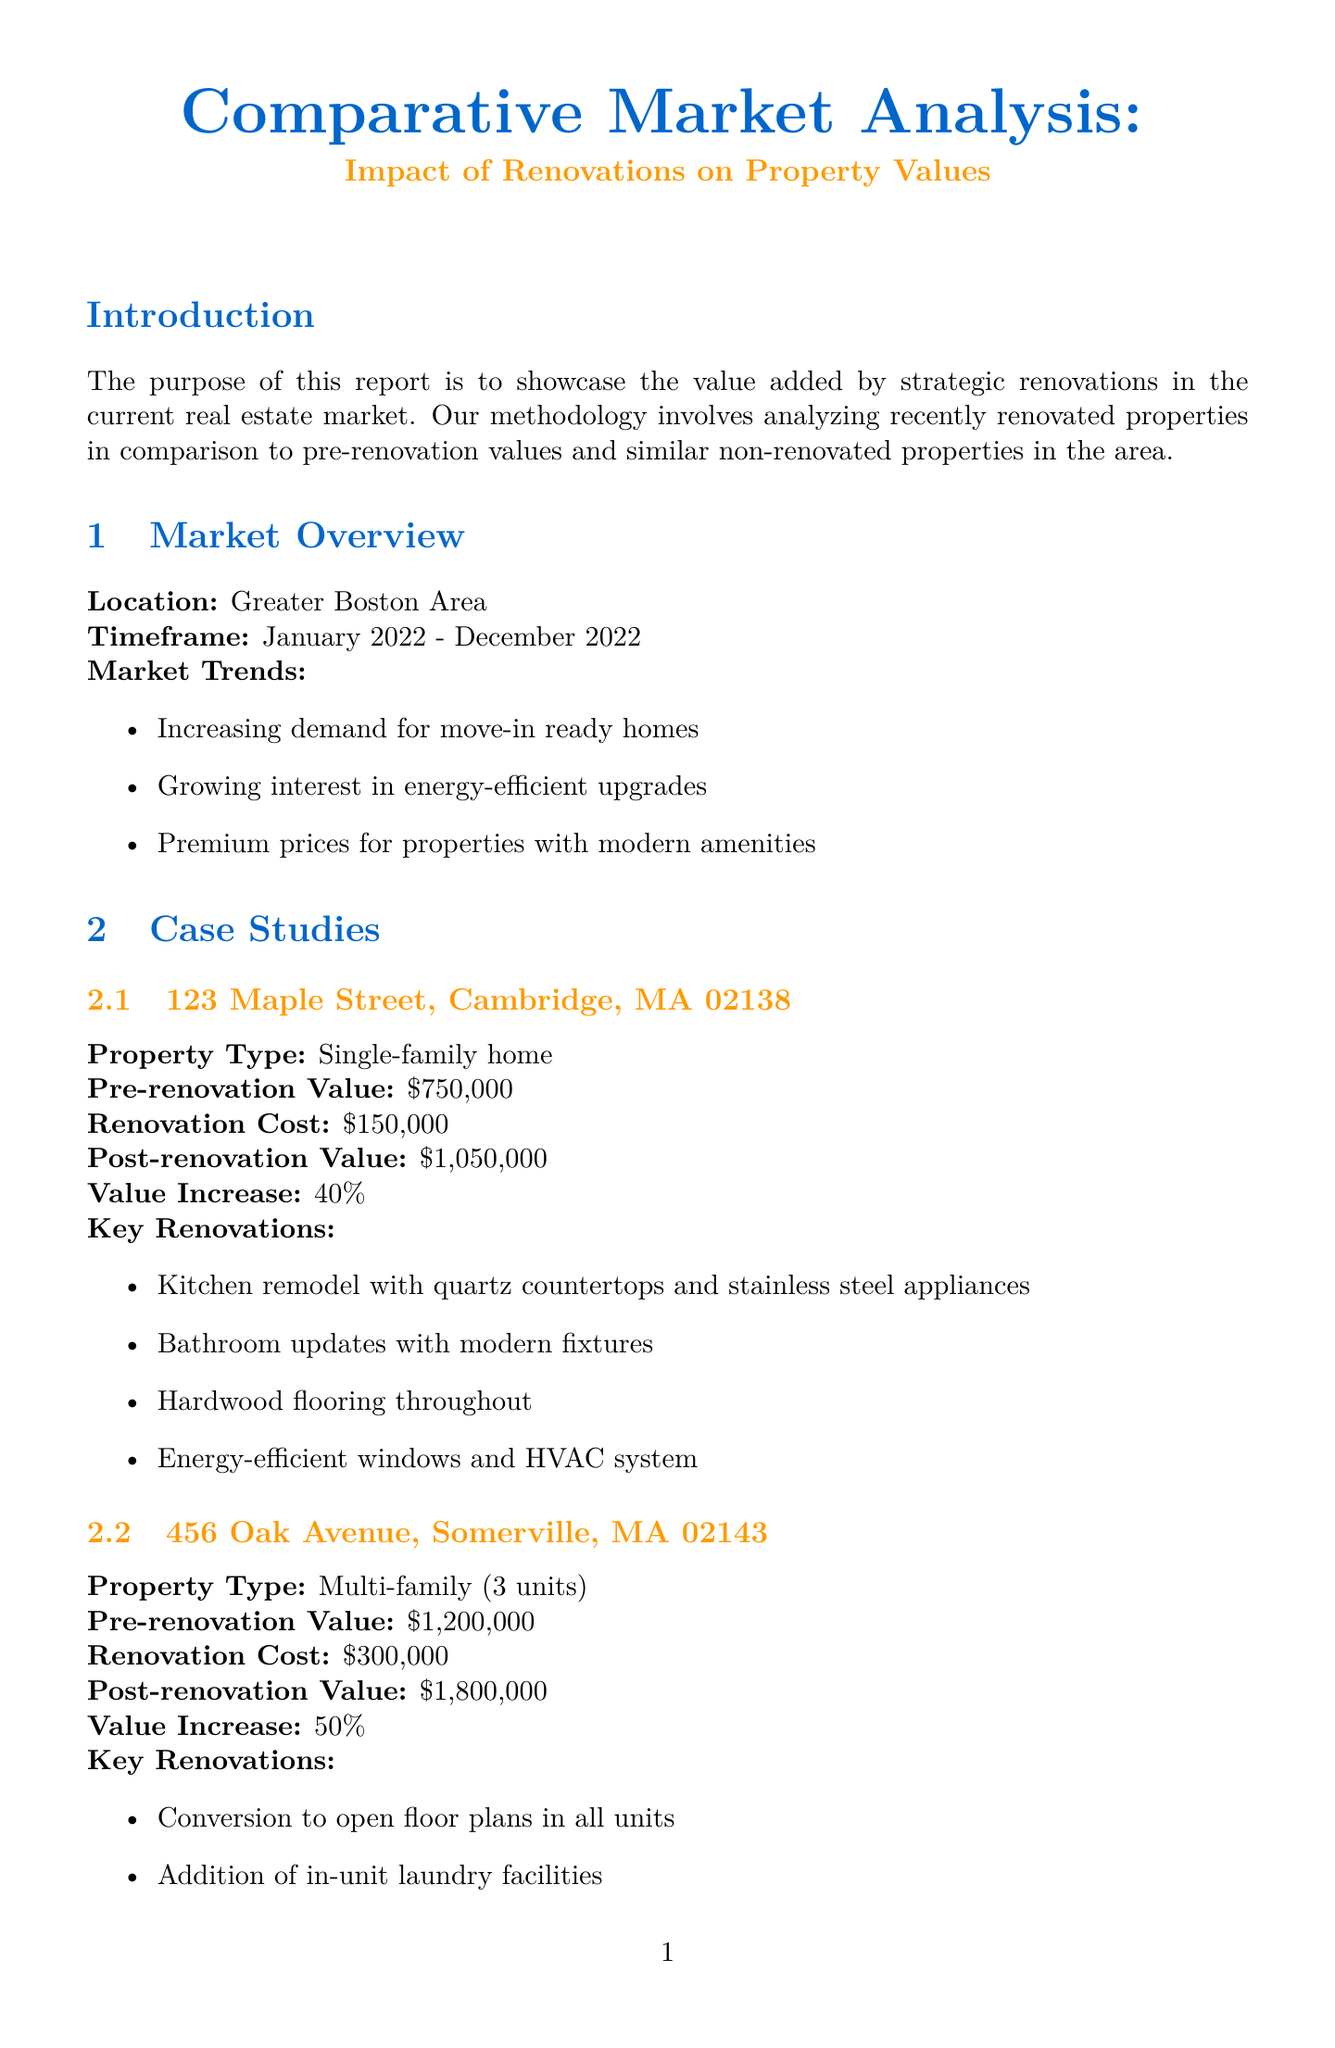what is the report title? The report title is directly mentioned at the beginning of the document.
Answer: Comparative Market Analysis: Impact of Renovations on Property Values what is the location covered in the market overview? The document specifies the geographic area for analysis in the market overview section.
Answer: Greater Boston Area what is the average value increase for renovated properties? The average value increase is stated in the comparative analysis section of the document.
Answer: 40.6% how much was the renovation cost for the property at 456 Oak Avenue? The renovation cost for each property is listed in the respective case study.
Answer: $300,000 what key renovation contributed to the highest value increase percentage? The document lists the case studies with their value increases, allowing for interpretation of the most impactful renovation.
Answer: Kitchen remodels how fast do renovated properties sell compared to non-renovated properties? This information is provided in the market implications section.
Answer: 30% faster what is the ROI range mentioned in the document? The document provides a specific range for ROI in the comparative analysis section.
Answer: 125% - 166% who is the author of the report? The author details are provided at the end of the document.
Answer: Sarah Johnson 